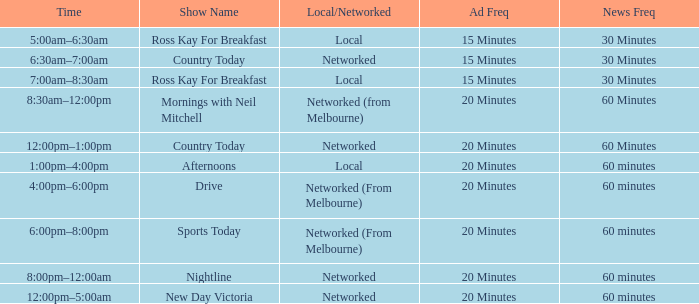What time is the program titled mornings with neil mitchell? 8:30am–12:00pm. Would you be able to parse every entry in this table? {'header': ['Time', 'Show Name', 'Local/Networked', 'Ad Freq', 'News Freq'], 'rows': [['5:00am–6:30am', 'Ross Kay For Breakfast', 'Local', '15 Minutes', '30 Minutes'], ['6:30am–7:00am', 'Country Today', 'Networked', '15 Minutes', '30 Minutes'], ['7:00am–8:30am', 'Ross Kay For Breakfast', 'Local', '15 Minutes', '30 Minutes'], ['8:30am–12:00pm', 'Mornings with Neil Mitchell', 'Networked (from Melbourne)', '20 Minutes', '60 Minutes'], ['12:00pm–1:00pm', 'Country Today', 'Networked', '20 Minutes', '60 Minutes'], ['1:00pm–4:00pm', 'Afternoons', 'Local', '20 Minutes', '60 minutes'], ['4:00pm–6:00pm', 'Drive', 'Networked (From Melbourne)', '20 Minutes', '60 minutes'], ['6:00pm–8:00pm', 'Sports Today', 'Networked (From Melbourne)', '20 Minutes', '60 minutes'], ['8:00pm–12:00am', 'Nightline', 'Networked', '20 Minutes', '60 minutes'], ['12:00pm–5:00am', 'New Day Victoria', 'Networked', '20 Minutes', '60 minutes']]} 